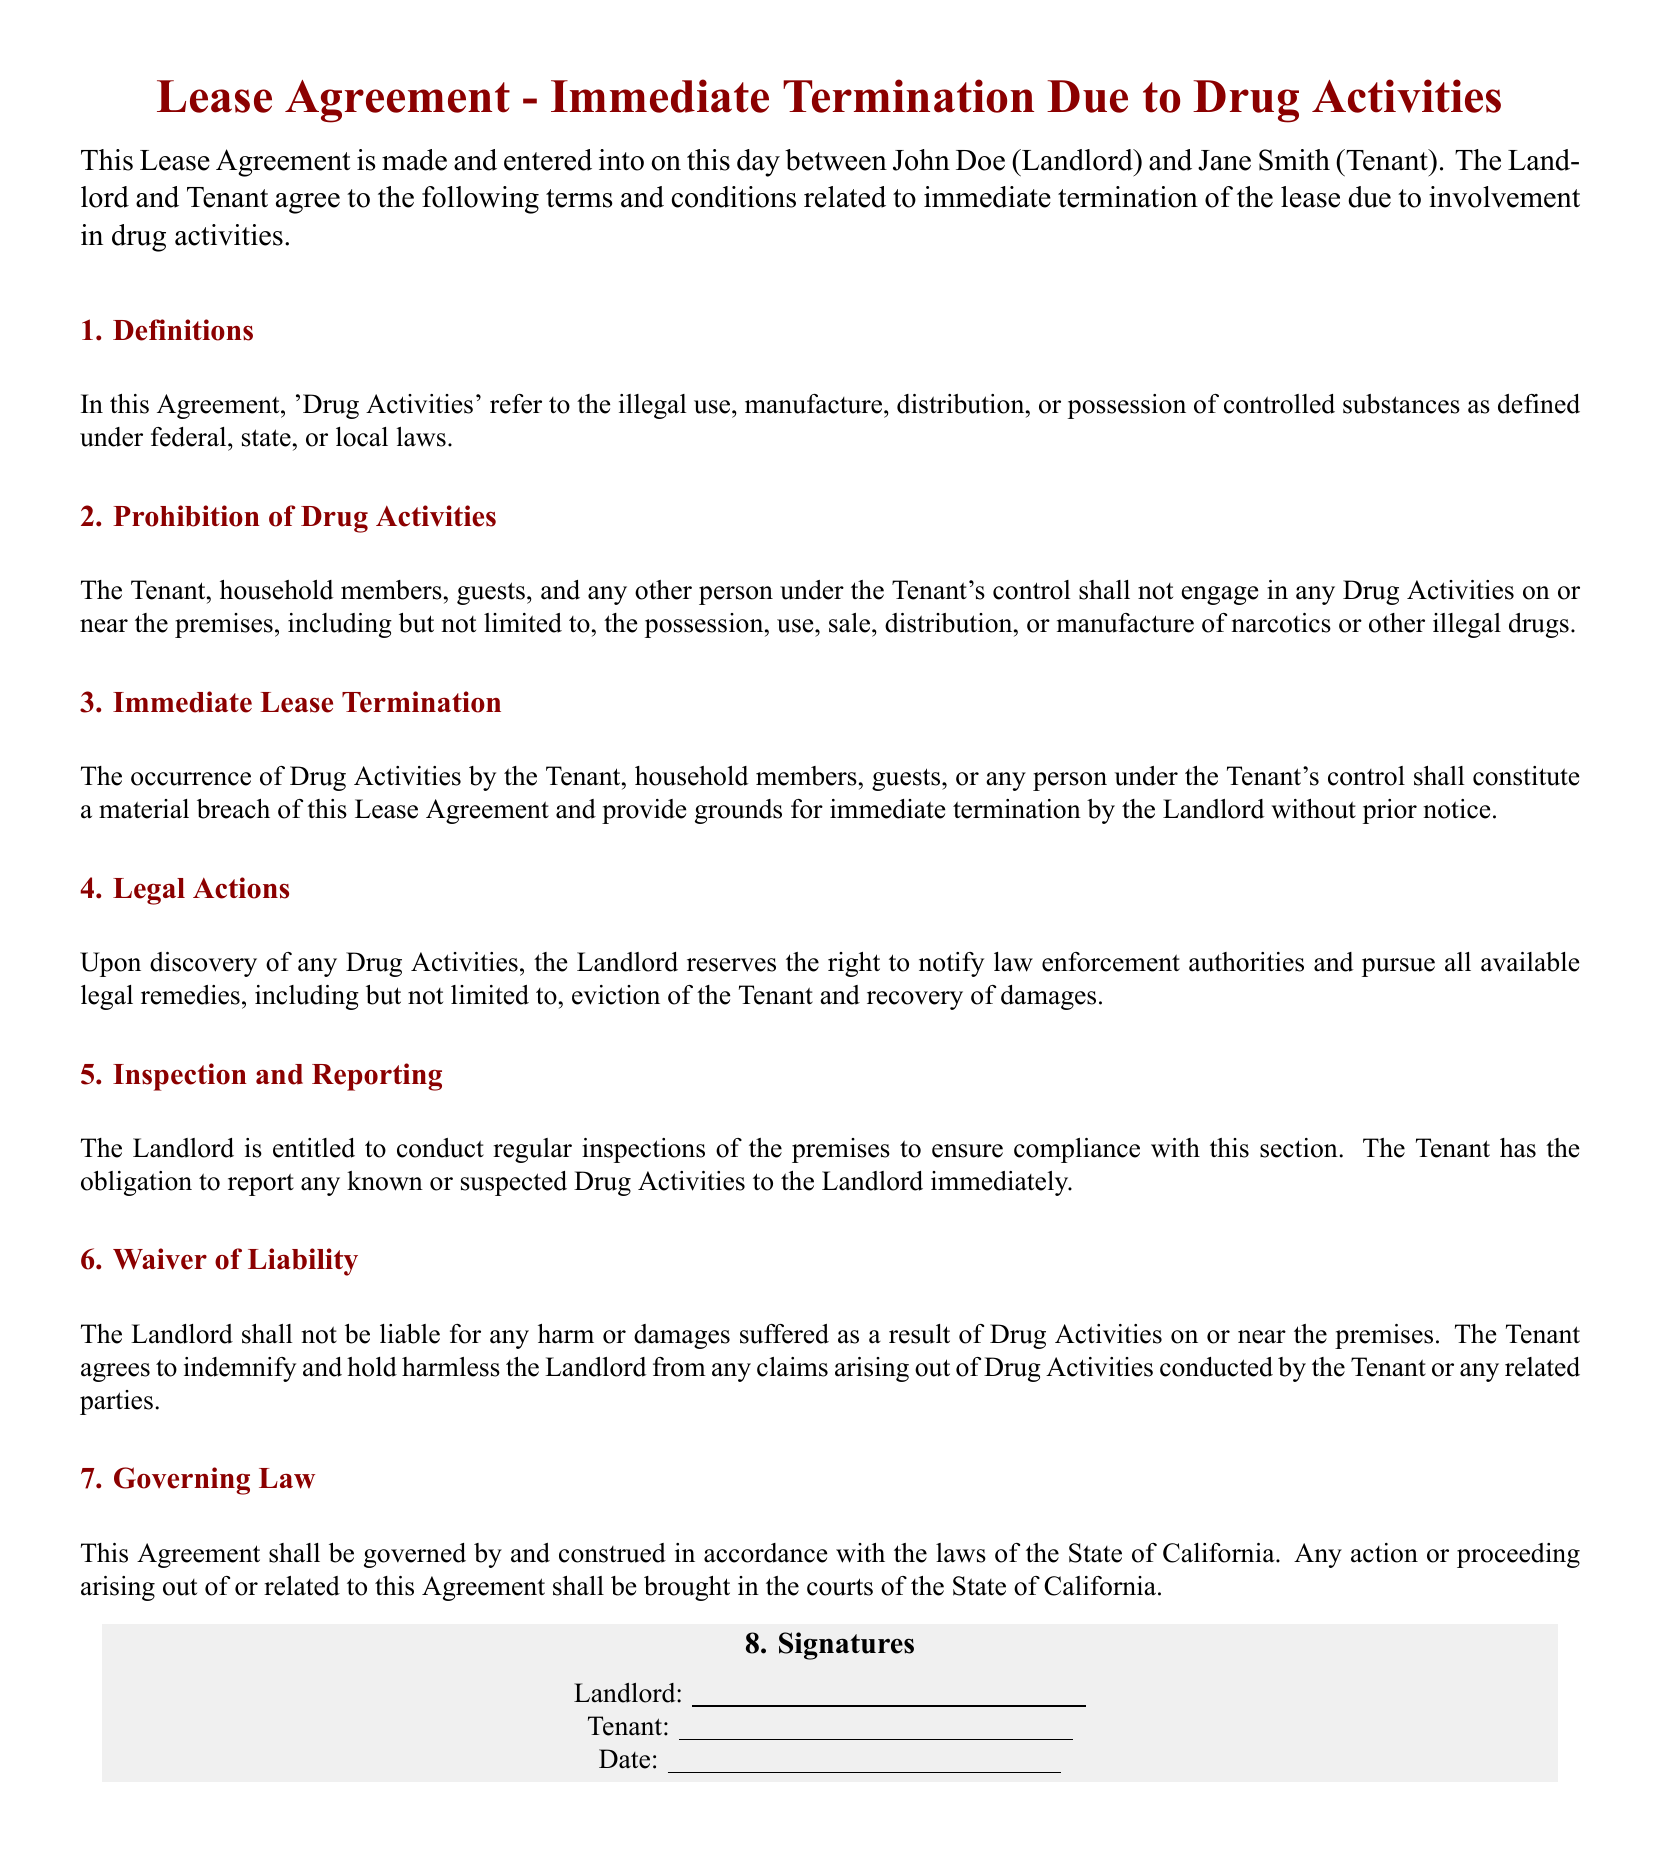What are 'Drug Activities'? 'Drug Activities' refers to the illegal use, manufacture, distribution, or possession of controlled substances as defined under federal, state, or local laws.
Answer: illegal use, manufacture, distribution, or possession of controlled substances Who is the Tenant in this Lease Agreement? The Tenant is named as Jane Smith in this lease agreement.
Answer: Jane Smith What is a consequence of engaging in Drug Activities? Engaging in Drug Activities constitutes a material breach of the Lease Agreement and provides grounds for immediate termination by the Landlord without prior notice.
Answer: immediate termination Is the Landlord liable for damages caused by Drug Activities? The Landlord shall not be liable for any harm or damages suffered as a result of Drug Activities on or near the premises.
Answer: Not liable What must the Tenant do if they suspect Drug Activities? The Tenant has the obligation to report any known or suspected Drug Activities to the Landlord immediately.
Answer: report immediately In which state is this Lease Agreement governed? This Agreement shall be governed by and construed in accordance with the laws of the State of California.
Answer: California 